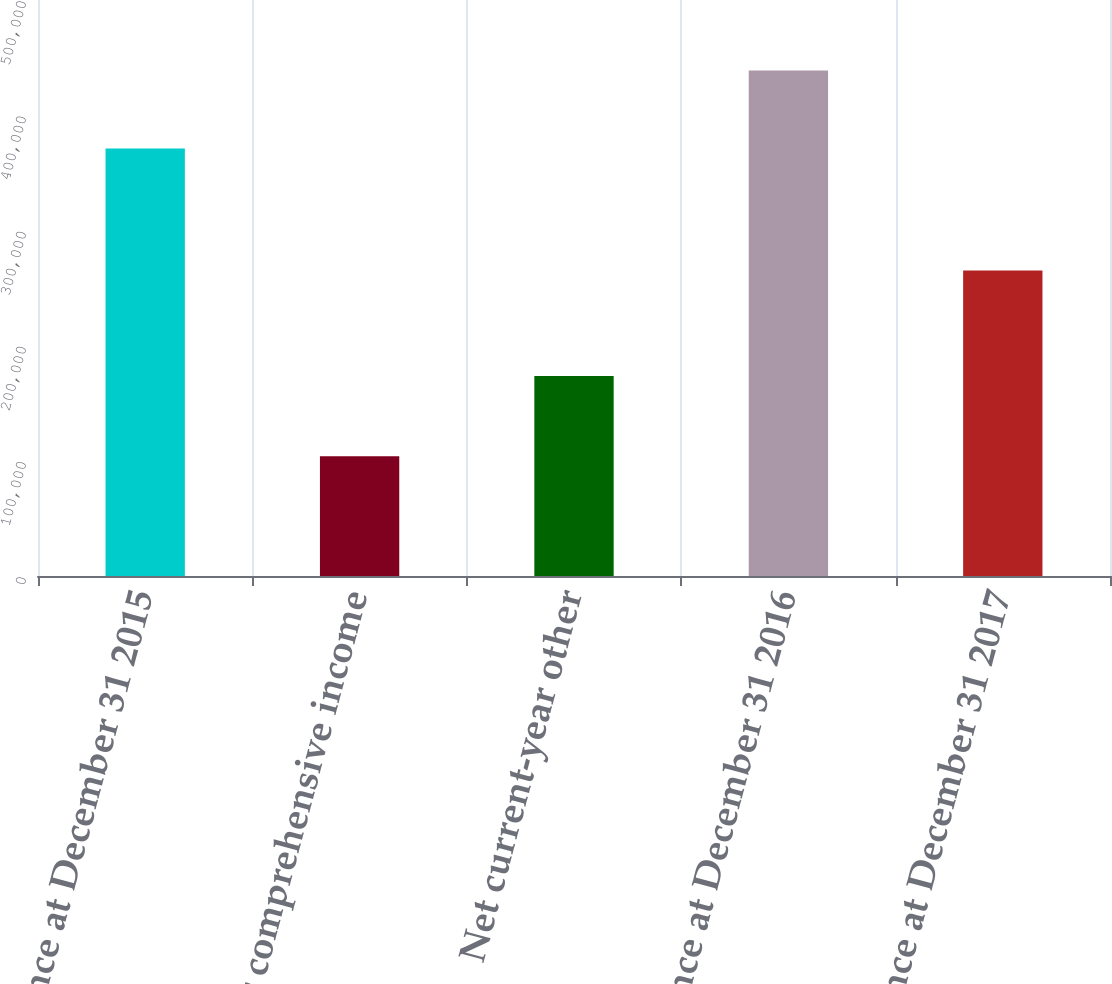Convert chart to OTSL. <chart><loc_0><loc_0><loc_500><loc_500><bar_chart><fcel>Balance at December 31 2015<fcel>Other comprehensive income<fcel>Net current-year other<fcel>Balance at December 31 2016<fcel>Balance at December 31 2017<nl><fcel>371124<fcel>103957<fcel>173626<fcel>438717<fcel>265091<nl></chart> 